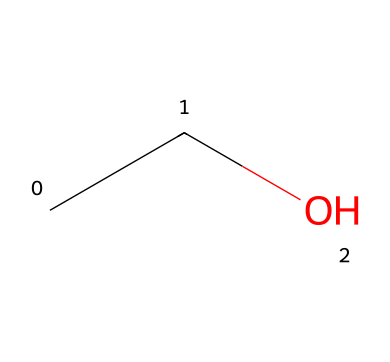What is the chemical name of this molecule? The SMILES representation "CCO" corresponds to a structure with two carbon atoms and one oxygen atom, which defines the chemical as ethanol.
Answer: ethanol How many carbon atoms are in this molecule? By examining the SMILES representation "CCO", we can identify that there are two carbon atoms (indicated by the two "C" characters).
Answer: 2 How many oxygen atoms are in this molecule? The SMILES "CCO" contains one "O", indicating that there is one oxygen atom present in the molecular structure.
Answer: 1 What type of solvent is ethanol classified as? Ethanol is commonly classified under polar solvents due to its ability to dissolve both polar and some nonpolar substances, which is observable in its molecular structure and functional groups.
Answer: polar What functional group is present in this chemical structure? In the SMILES representation "CCO", the "O" bonded to the "C" indicates the presence of a hydroxyl functional group (-OH), defining ethanol as an alcohol.
Answer: hydroxyl Is this solvent hydrophilic or hydrophobic? Ethanol has a hydroxyl group which makes it hydrophilic, allowing it to interact favorably with water molecules, thus it can form hydrogen bonds with them.
Answer: hydrophilic What is the total number of bonds in this molecule? Analyzing the "CCO", we can deduce that there are single covalent bonds between the carbon atoms and between carbon and oxygen, resulting in a total of five bonds.
Answer: 5 